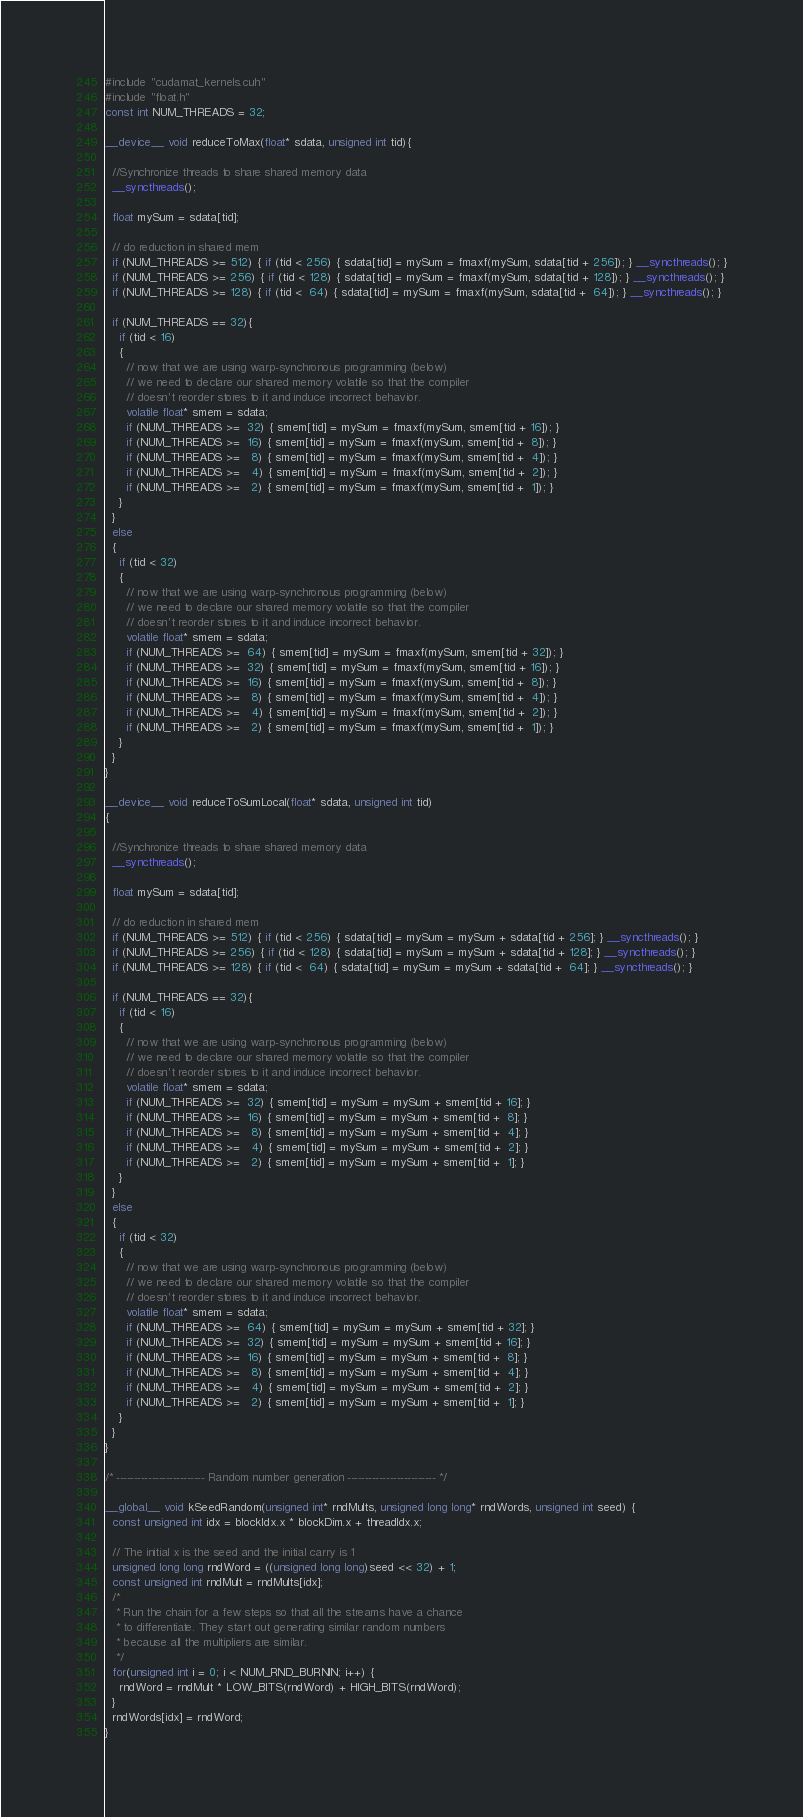<code> <loc_0><loc_0><loc_500><loc_500><_Cuda_>#include "cudamat_kernels.cuh"
#include "float.h"
const int NUM_THREADS = 32;

__device__ void reduceToMax(float* sdata, unsigned int tid){

  //Synchronize threads to share shared memory data
  __syncthreads();

  float mySum = sdata[tid];

  // do reduction in shared mem
  if (NUM_THREADS >= 512) { if (tid < 256) { sdata[tid] = mySum = fmaxf(mySum, sdata[tid + 256]); } __syncthreads(); }
  if (NUM_THREADS >= 256) { if (tid < 128) { sdata[tid] = mySum = fmaxf(mySum, sdata[tid + 128]); } __syncthreads(); }
  if (NUM_THREADS >= 128) { if (tid <  64) { sdata[tid] = mySum = fmaxf(mySum, sdata[tid +  64]); } __syncthreads(); }

  if (NUM_THREADS == 32){
    if (tid < 16)
    {
      // now that we are using warp-synchronous programming (below)
      // we need to declare our shared memory volatile so that the compiler
      // doesn't reorder stores to it and induce incorrect behavior.
      volatile float* smem = sdata;
      if (NUM_THREADS >=  32) { smem[tid] = mySum = fmaxf(mySum, smem[tid + 16]); }
      if (NUM_THREADS >=  16) { smem[tid] = mySum = fmaxf(mySum, smem[tid +  8]); }
      if (NUM_THREADS >=   8) { smem[tid] = mySum = fmaxf(mySum, smem[tid +  4]); }
      if (NUM_THREADS >=   4) { smem[tid] = mySum = fmaxf(mySum, smem[tid +  2]); }
      if (NUM_THREADS >=   2) { smem[tid] = mySum = fmaxf(mySum, smem[tid +  1]); }
    }
  }
  else
  {
    if (tid < 32)
    {
      // now that we are using warp-synchronous programming (below)
      // we need to declare our shared memory volatile so that the compiler
      // doesn't reorder stores to it and induce incorrect behavior.
      volatile float* smem = sdata;
      if (NUM_THREADS >=  64) { smem[tid] = mySum = fmaxf(mySum, smem[tid + 32]); }
      if (NUM_THREADS >=  32) { smem[tid] = mySum = fmaxf(mySum, smem[tid + 16]); }
      if (NUM_THREADS >=  16) { smem[tid] = mySum = fmaxf(mySum, smem[tid +  8]); }
      if (NUM_THREADS >=   8) { smem[tid] = mySum = fmaxf(mySum, smem[tid +  4]); }
      if (NUM_THREADS >=   4) { smem[tid] = mySum = fmaxf(mySum, smem[tid +  2]); }
      if (NUM_THREADS >=   2) { smem[tid] = mySum = fmaxf(mySum, smem[tid +  1]); }
    }
  }
}

__device__ void reduceToSumLocal(float* sdata, unsigned int tid)
{

  //Synchronize threads to share shared memory data
  __syncthreads();

  float mySum = sdata[tid];

  // do reduction in shared mem
  if (NUM_THREADS >= 512) { if (tid < 256) { sdata[tid] = mySum = mySum + sdata[tid + 256]; } __syncthreads(); }
  if (NUM_THREADS >= 256) { if (tid < 128) { sdata[tid] = mySum = mySum + sdata[tid + 128]; } __syncthreads(); }
  if (NUM_THREADS >= 128) { if (tid <  64) { sdata[tid] = mySum = mySum + sdata[tid +  64]; } __syncthreads(); }

  if (NUM_THREADS == 32){
    if (tid < 16)
    {
      // now that we are using warp-synchronous programming (below)
      // we need to declare our shared memory volatile so that the compiler
      // doesn't reorder stores to it and induce incorrect behavior.
      volatile float* smem = sdata;
      if (NUM_THREADS >=  32) { smem[tid] = mySum = mySum + smem[tid + 16]; }
      if (NUM_THREADS >=  16) { smem[tid] = mySum = mySum + smem[tid +  8]; }
      if (NUM_THREADS >=   8) { smem[tid] = mySum = mySum + smem[tid +  4]; }
      if (NUM_THREADS >=   4) { smem[tid] = mySum = mySum + smem[tid +  2]; }
      if (NUM_THREADS >=   2) { smem[tid] = mySum = mySum + smem[tid +  1]; }
    }
  }
  else
  {
    if (tid < 32)
    {
      // now that we are using warp-synchronous programming (below)
      // we need to declare our shared memory volatile so that the compiler
      // doesn't reorder stores to it and induce incorrect behavior.
      volatile float* smem = sdata;
      if (NUM_THREADS >=  64) { smem[tid] = mySum = mySum + smem[tid + 32]; }
      if (NUM_THREADS >=  32) { smem[tid] = mySum = mySum + smem[tid + 16]; }
      if (NUM_THREADS >=  16) { smem[tid] = mySum = mySum + smem[tid +  8]; }
      if (NUM_THREADS >=   8) { smem[tid] = mySum = mySum + smem[tid +  4]; }
      if (NUM_THREADS >=   4) { smem[tid] = mySum = mySum + smem[tid +  2]; }
      if (NUM_THREADS >=   2) { smem[tid] = mySum = mySum + smem[tid +  1]; }
    }
  }
}

/* ------------------------- Random number generation ------------------------- */

__global__ void kSeedRandom(unsigned int* rndMults, unsigned long long* rndWords, unsigned int seed) {
  const unsigned int idx = blockIdx.x * blockDim.x + threadIdx.x;

  // The initial x is the seed and the initial carry is 1
  unsigned long long rndWord = ((unsigned long long)seed << 32) + 1;
  const unsigned int rndMult = rndMults[idx];
  /*
   * Run the chain for a few steps so that all the streams have a chance
   * to differentiate. They start out generating similar random numbers
   * because all the multipliers are similar.
   */
  for(unsigned int i = 0; i < NUM_RND_BURNIN; i++) {
    rndWord = rndMult * LOW_BITS(rndWord) + HIGH_BITS(rndWord);
  }
  rndWords[idx] = rndWord;
}
</code> 